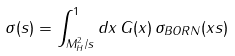<formula> <loc_0><loc_0><loc_500><loc_500>\sigma ( s ) = \int _ { M _ { H } ^ { 2 } / s } ^ { 1 } d x \, G ( x ) \, \sigma _ { B O R N } ( x s )</formula> 